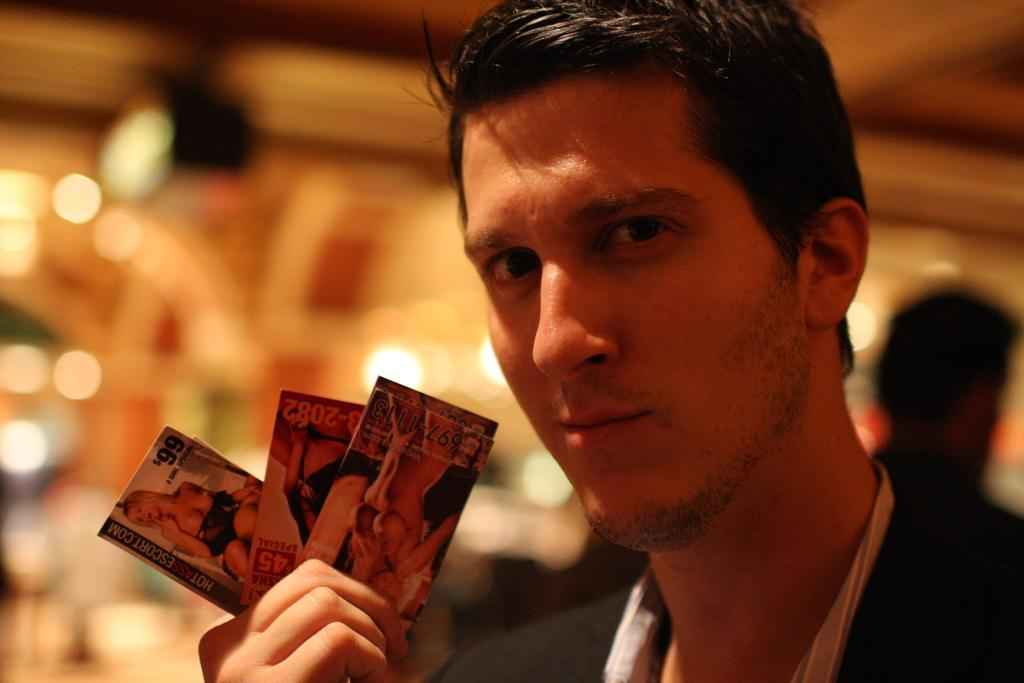Who is the main subject in the image? There is a man in the image. What is the man holding in his hand? The man is holding cards in his hand. Can you describe the person visible at the back of the man? There is a person visible at the back of the man, but no specific details are provided. What objects can be seen at the back of the man? Some objects are visible at the back of the man, but no specific details are provided. How would you describe the background of the image? The background is blurry. What type of boats can be seen in the image? There are no boats present in the image. What is the texture of the low-hanging clouds in the image? There are no clouds mentioned in the image, so it is not possible to determine their texture. 